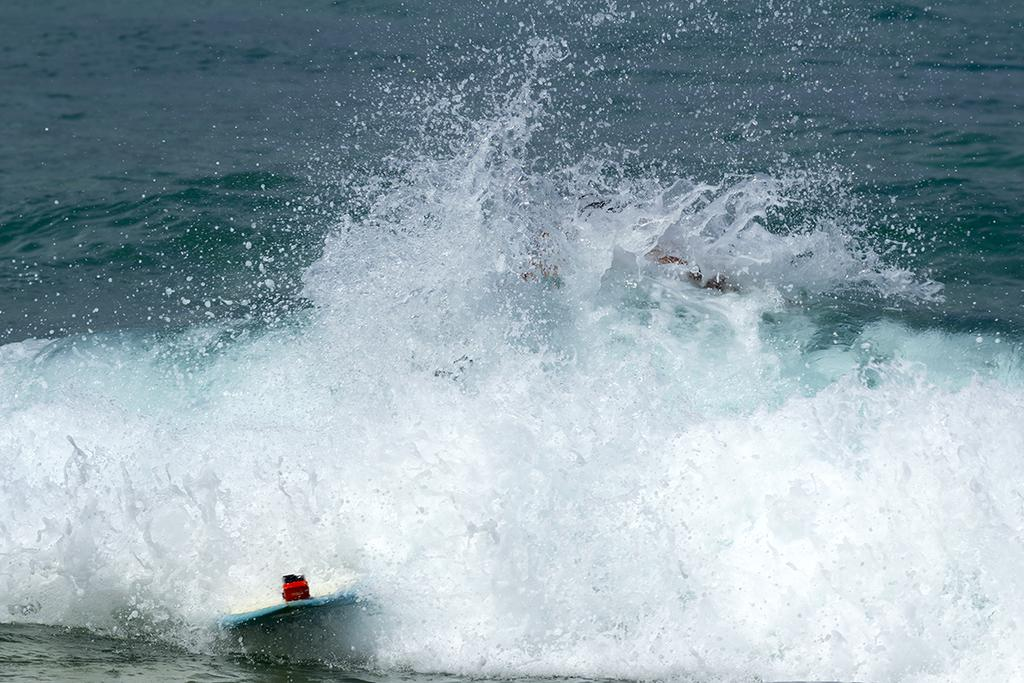What is the main subject in the center of the image? There is water in the center of the image. What can be seen floating on the water? There are boats in the water. What type of button is being used to control the boats in the image? There is no button present in the image, and the boats are not being controlled by any visible means. 